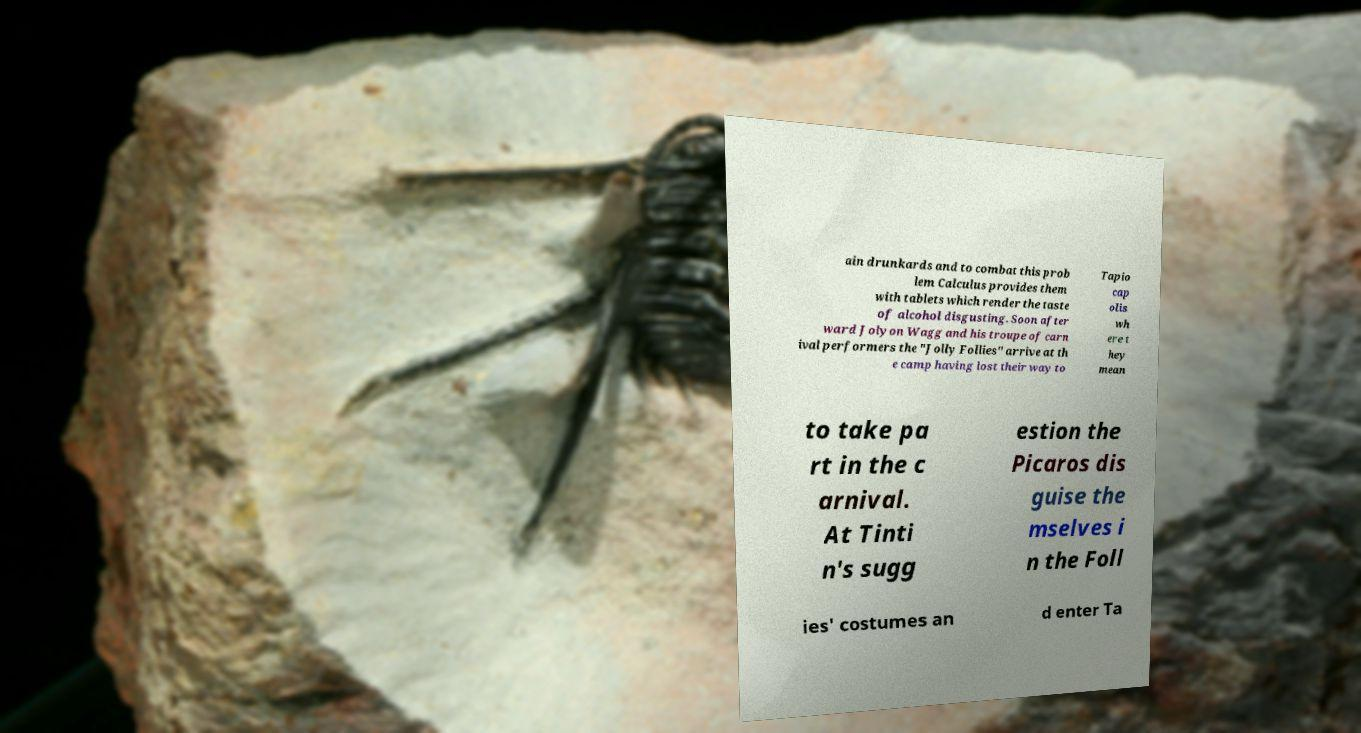For documentation purposes, I need the text within this image transcribed. Could you provide that? ain drunkards and to combat this prob lem Calculus provides them with tablets which render the taste of alcohol disgusting. Soon after ward Jolyon Wagg and his troupe of carn ival performers the "Jolly Follies" arrive at th e camp having lost their way to Tapio cap olis wh ere t hey mean to take pa rt in the c arnival. At Tinti n's sugg estion the Picaros dis guise the mselves i n the Foll ies' costumes an d enter Ta 